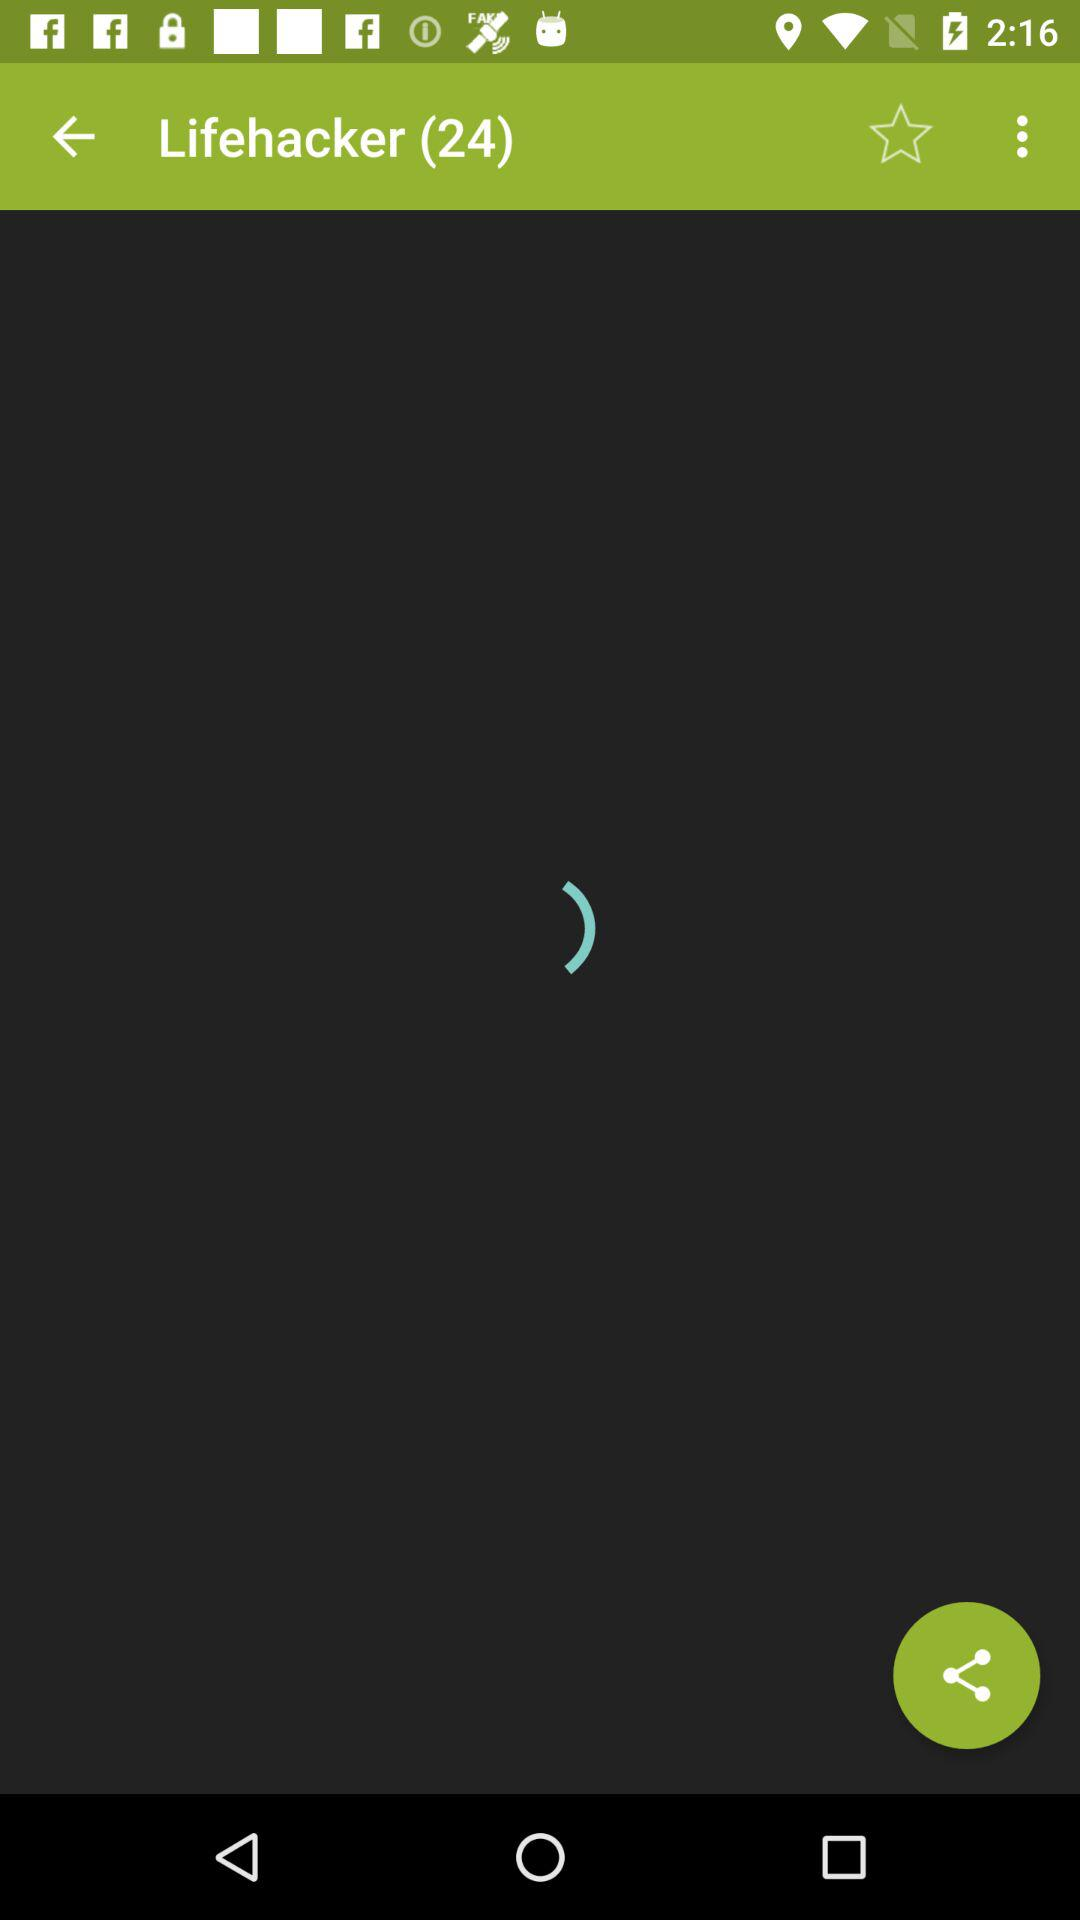How many lifehackers are there? There are 24 lifehackers. 